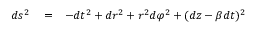Convert formula to latex. <formula><loc_0><loc_0><loc_500><loc_500>\begin{array} { r l r } { d s ^ { 2 } } & = } & { - d t ^ { 2 } + d r ^ { 2 } + r ^ { 2 } d \varphi ^ { 2 } + ( d z - \beta d t ) ^ { 2 } } \end{array}</formula> 